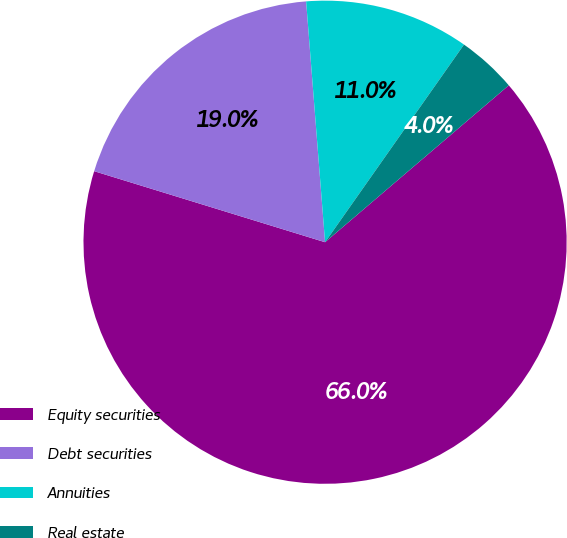Convert chart to OTSL. <chart><loc_0><loc_0><loc_500><loc_500><pie_chart><fcel>Equity securities<fcel>Debt securities<fcel>Annuities<fcel>Real estate<nl><fcel>66.0%<fcel>19.0%<fcel>11.0%<fcel>4.0%<nl></chart> 